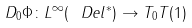Convert formula to latex. <formula><loc_0><loc_0><loc_500><loc_500>D _ { 0 } \Phi \colon L ^ { \infty } ( \ D e l ^ { * } ) \rightarrow T _ { 0 } T ( 1 )</formula> 